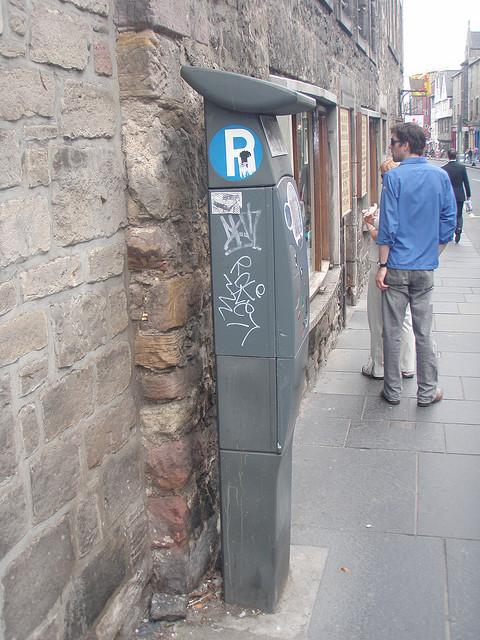Which likely came first, the sidewalk/building or the gray box?
Concise answer only. Building. How many bricks make up the sidewalk?
Give a very brief answer. Lot. What does the blue sign indicate?
Give a very brief answer. Parking. 